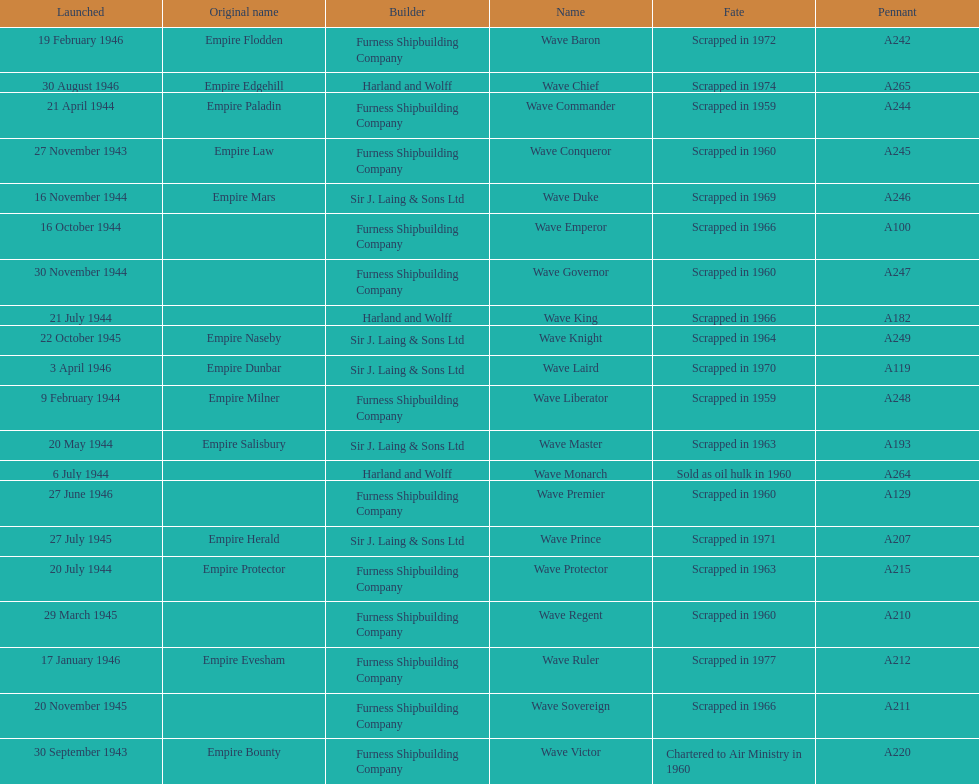Which other ship was launched in the same year as the wave victor? Wave Conqueror. 